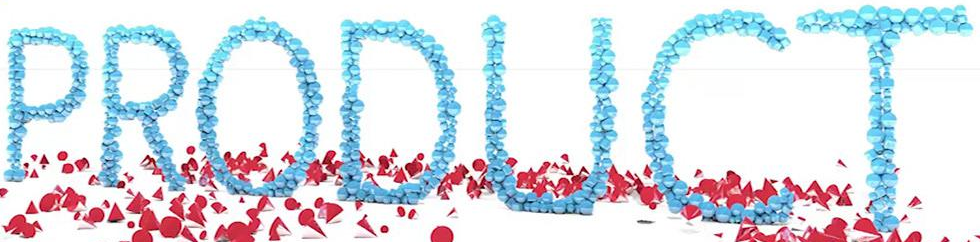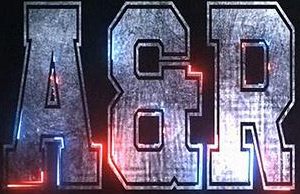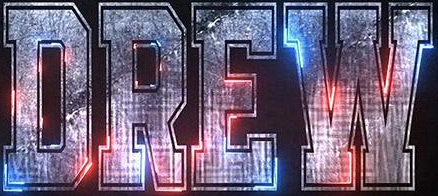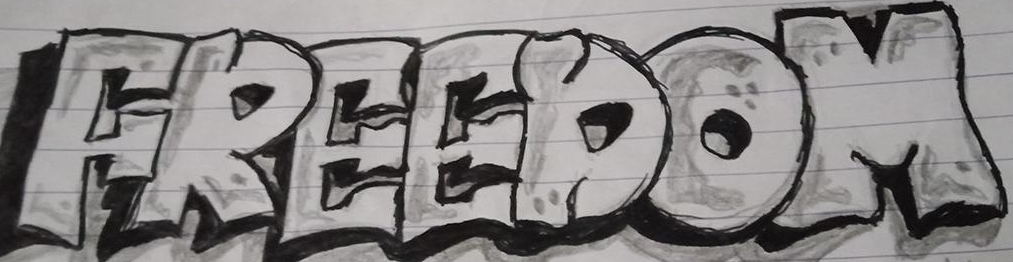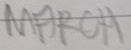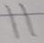What text is displayed in these images sequentially, separated by a semicolon? PRODUCT; AER; DREW; FREEDOM; MARCH; 11 